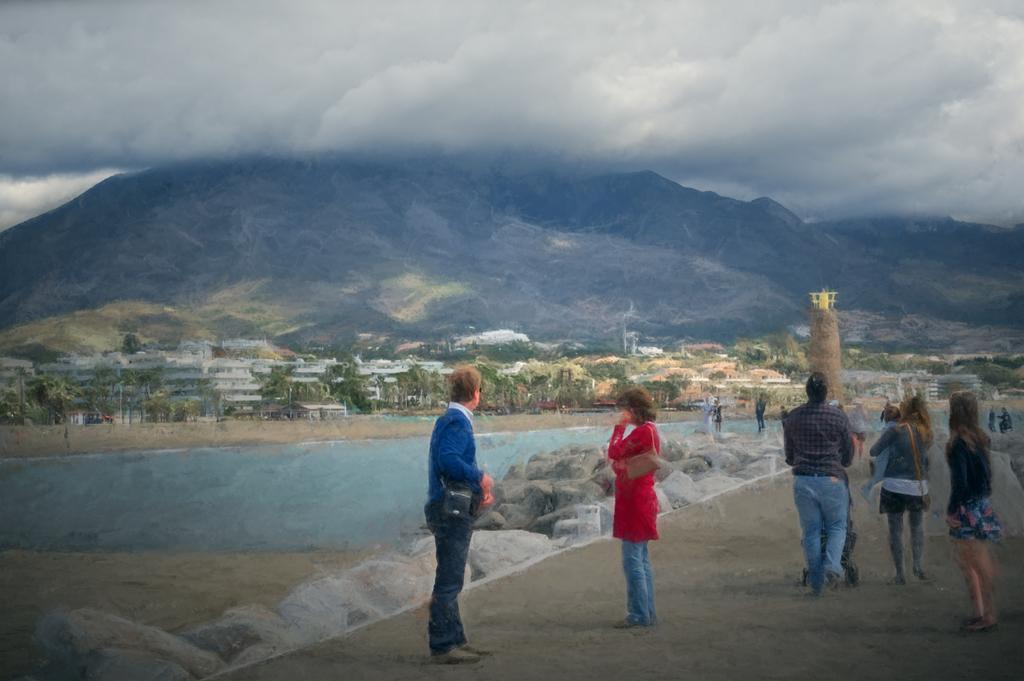Please provide a concise description of this image. In this picture we can see people on the ground, here we can see some stones, buildings, trees and some objects and in the background we can see mountains, sky. 